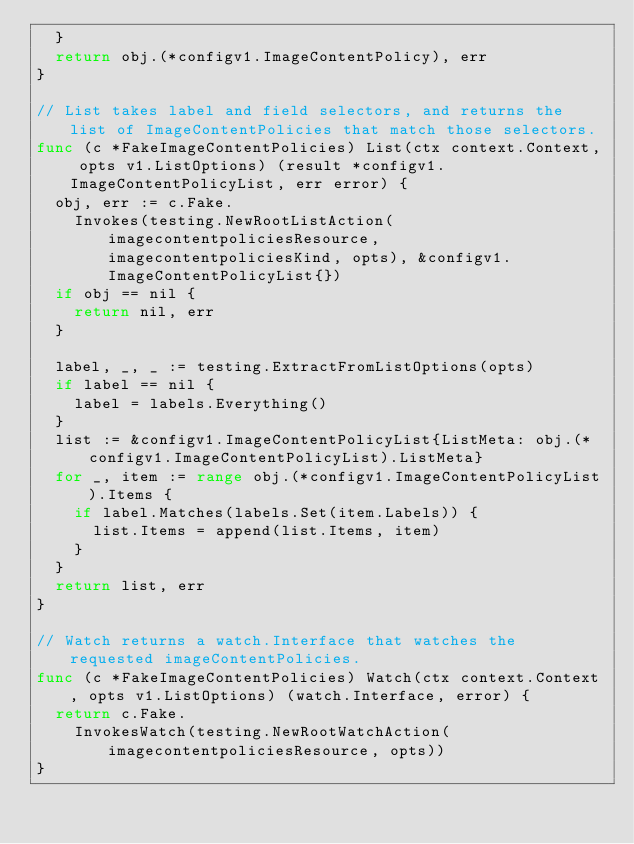Convert code to text. <code><loc_0><loc_0><loc_500><loc_500><_Go_>	}
	return obj.(*configv1.ImageContentPolicy), err
}

// List takes label and field selectors, and returns the list of ImageContentPolicies that match those selectors.
func (c *FakeImageContentPolicies) List(ctx context.Context, opts v1.ListOptions) (result *configv1.ImageContentPolicyList, err error) {
	obj, err := c.Fake.
		Invokes(testing.NewRootListAction(imagecontentpoliciesResource, imagecontentpoliciesKind, opts), &configv1.ImageContentPolicyList{})
	if obj == nil {
		return nil, err
	}

	label, _, _ := testing.ExtractFromListOptions(opts)
	if label == nil {
		label = labels.Everything()
	}
	list := &configv1.ImageContentPolicyList{ListMeta: obj.(*configv1.ImageContentPolicyList).ListMeta}
	for _, item := range obj.(*configv1.ImageContentPolicyList).Items {
		if label.Matches(labels.Set(item.Labels)) {
			list.Items = append(list.Items, item)
		}
	}
	return list, err
}

// Watch returns a watch.Interface that watches the requested imageContentPolicies.
func (c *FakeImageContentPolicies) Watch(ctx context.Context, opts v1.ListOptions) (watch.Interface, error) {
	return c.Fake.
		InvokesWatch(testing.NewRootWatchAction(imagecontentpoliciesResource, opts))
}
</code> 